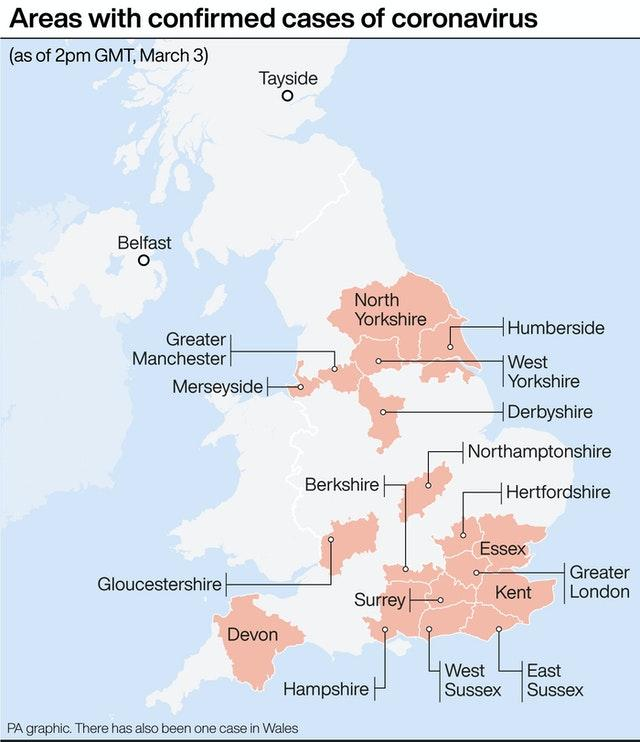Highlight a few significant elements in this photo. There are 19 places that are shown in pink color. 